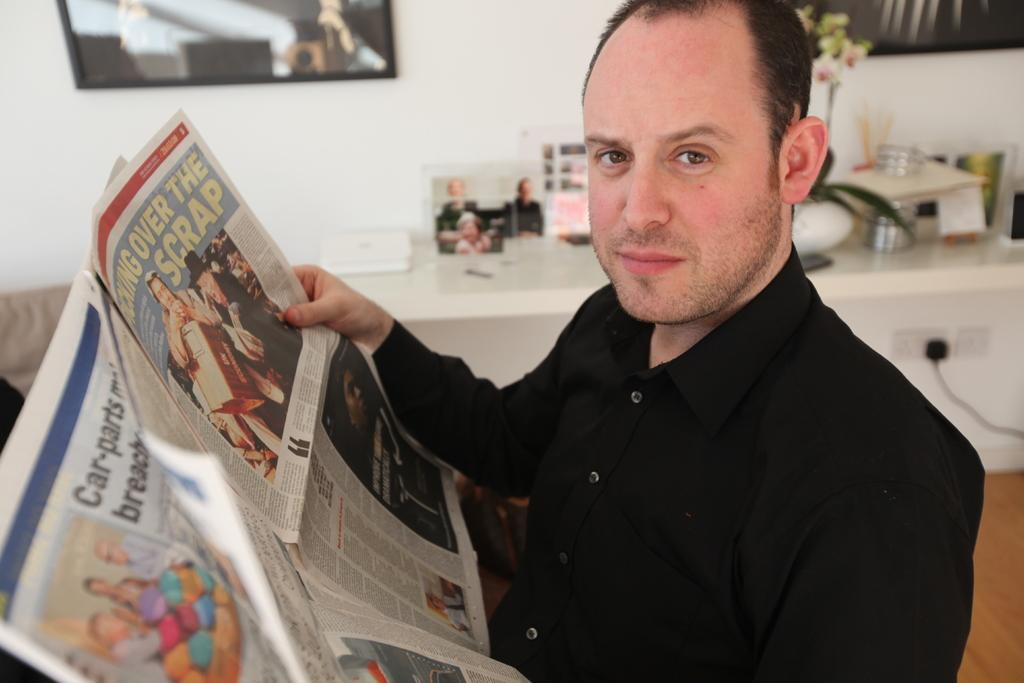What three letter word is printed in the top right corner of the newspaper?
Give a very brief answer. The. 